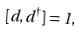Convert formula to latex. <formula><loc_0><loc_0><loc_500><loc_500>[ d , d ^ { \dagger } ] = 1 ,</formula> 